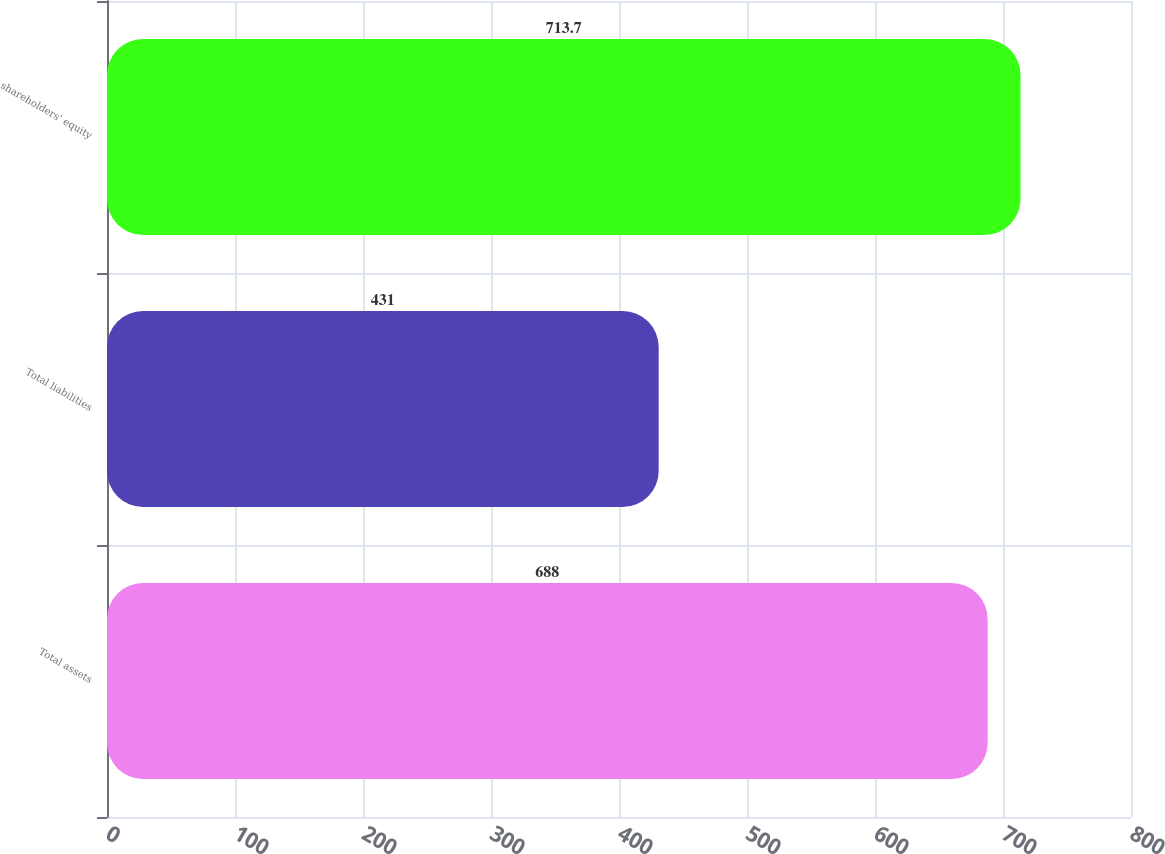Convert chart to OTSL. <chart><loc_0><loc_0><loc_500><loc_500><bar_chart><fcel>Total assets<fcel>Total liabilities<fcel>shareholders' equity<nl><fcel>688<fcel>431<fcel>713.7<nl></chart> 